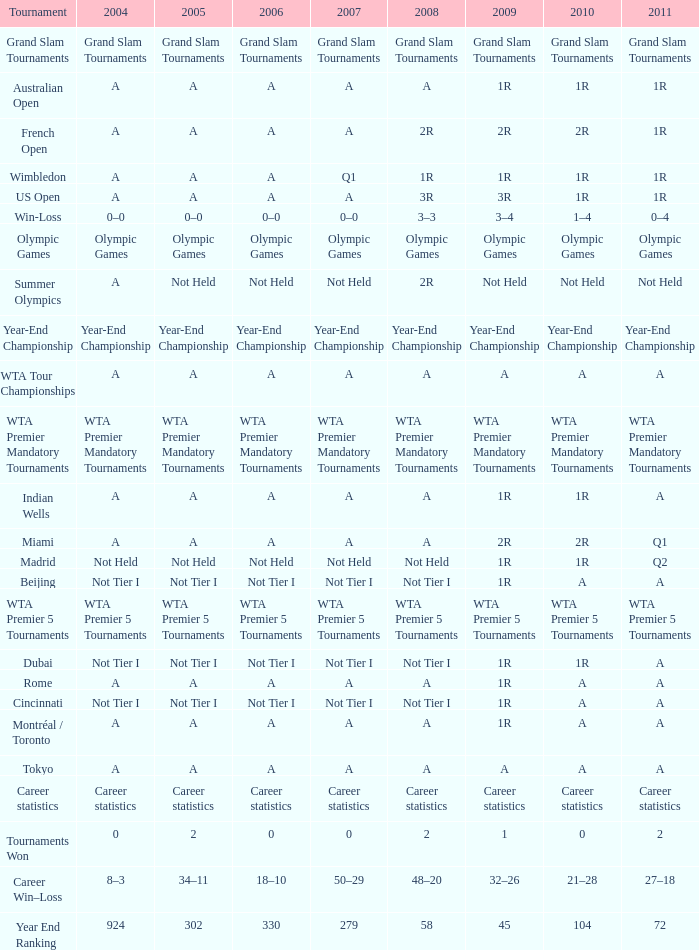What corresponds to 2011, when 2010 is "wta premier 5 tournaments"? WTA Premier 5 Tournaments. 